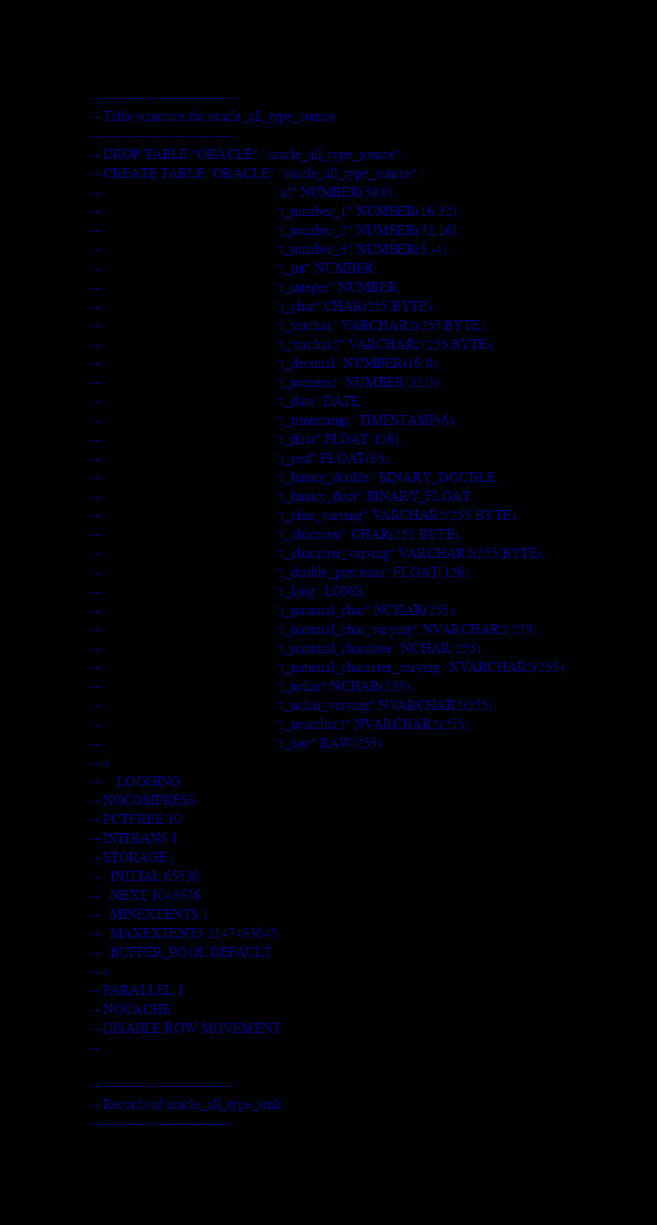<code> <loc_0><loc_0><loc_500><loc_500><_SQL_>-- ----------------------------
-- Table structure for oracle_all_type_source
-- ----------------------------
-- DROP TABLE "ORACLE"."oracle_all_type_source";
-- CREATE TABLE "ORACLE"."oracle_all_type_source" (
--                                                  "id" NUMBER(38,0),
--                                                  "t_number_1" NUMBER(16,32),
--                                                  "t_number_2" NUMBER(32,16),
--                                                  "t_number_3" NUMBER(8,-4),
--                                                  "t_int" NUMBER,
--                                                  "t_integer" NUMBER,
--                                                  "t_char" CHAR(255 BYTE),
--                                                  "t_varchar" VARCHAR2(255 BYTE),
--                                                  "t_varchar2" VARCHAR2(255 BYTE),
--                                                  "t_decimal" NUMBER(16,0),
--                                                  "t_numeric" NUMBER(32,0),
--                                                  "t_date" DATE,
--                                                  "t_timestamp" TIMESTAMP(6),
--                                                  "t_float" FLOAT(126),
--                                                  "t_real" FLOAT(63),
--                                                  "t_binary_double" BINARY_DOUBLE,
--                                                  "t_binary_float" BINARY_FLOAT,
--                                                  "t_char_varying" VARCHAR2(255 BYTE),
--                                                  "t_character" CHAR(255 BYTE),
--                                                  "t_character_varying" VARCHAR2(255 BYTE),
--                                                  "t_double_precision" FLOAT(126),
--                                                  "t_long" LONG,
--                                                  "t_national_char" NCHAR(255),
--                                                  "t_national_char_varying" NVARCHAR2(255),
--                                                  "t_national_character" NCHAR(255),
--                                                  "t_national_character_varying" NVARCHAR2(255),
--                                                  "t_nchar" NCHAR(255),
--                                                  "t_nchar_varying" NVARCHAR2(255),
--                                                  "t_nvarchar2" NVARCHAR2(255),
--                                                  "t_raw" RAW(255)
-- )
--     LOGGING
-- NOCOMPRESS
-- PCTFREE 10
-- INITRANS 1
-- STORAGE (
--   INITIAL 65536
--   NEXT 1048576
--   MINEXTENTS 1
--   MAXEXTENTS 2147483645
--   BUFFER_POOL DEFAULT
-- )
-- PARALLEL 1
-- NOCACHE
-- DISABLE ROW MOVEMENT
-- ;

-- ----------------------------
-- Records of oracle_all_type_sink
-- ----------------------------</code> 